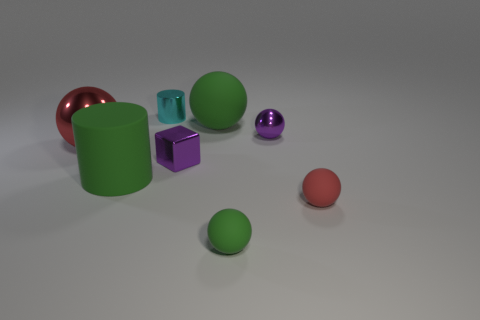Are there more large things that are left of the cyan cylinder than red spheres?
Offer a very short reply. No. How many other things are the same color as the matte cylinder?
Provide a short and direct response. 2. There is a red ball that is to the left of the red rubber object; is it the same size as the green rubber cylinder?
Your response must be concise. Yes. Are there any purple things of the same size as the green matte cylinder?
Your response must be concise. No. There is a small rubber thing that is to the left of the small red matte thing; what is its color?
Your answer should be very brief. Green. There is a matte object that is left of the red rubber thing and to the right of the large green ball; what is its shape?
Offer a very short reply. Sphere. What number of big green things have the same shape as the big red thing?
Provide a succinct answer. 1. What number of purple cylinders are there?
Your answer should be very brief. 0. What is the size of the sphere that is both behind the tiny block and on the right side of the big green matte ball?
Give a very brief answer. Small. What is the shape of the red thing that is the same size as the purple metal ball?
Your answer should be very brief. Sphere. 